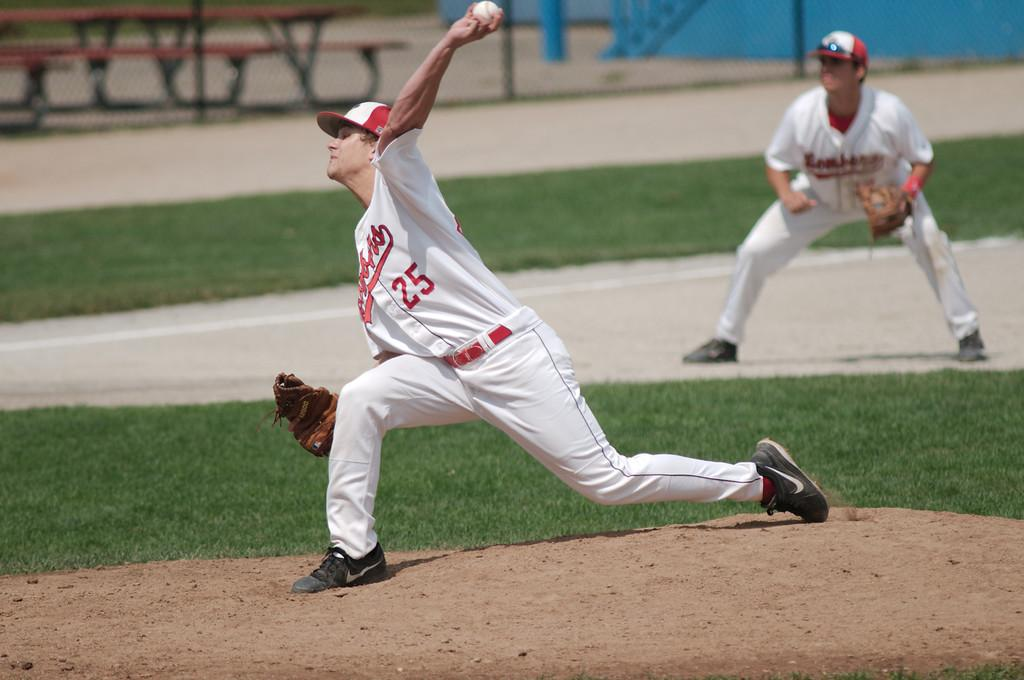<image>
Present a compact description of the photo's key features. Baseball player wearing a white jersey that has the number 25. 